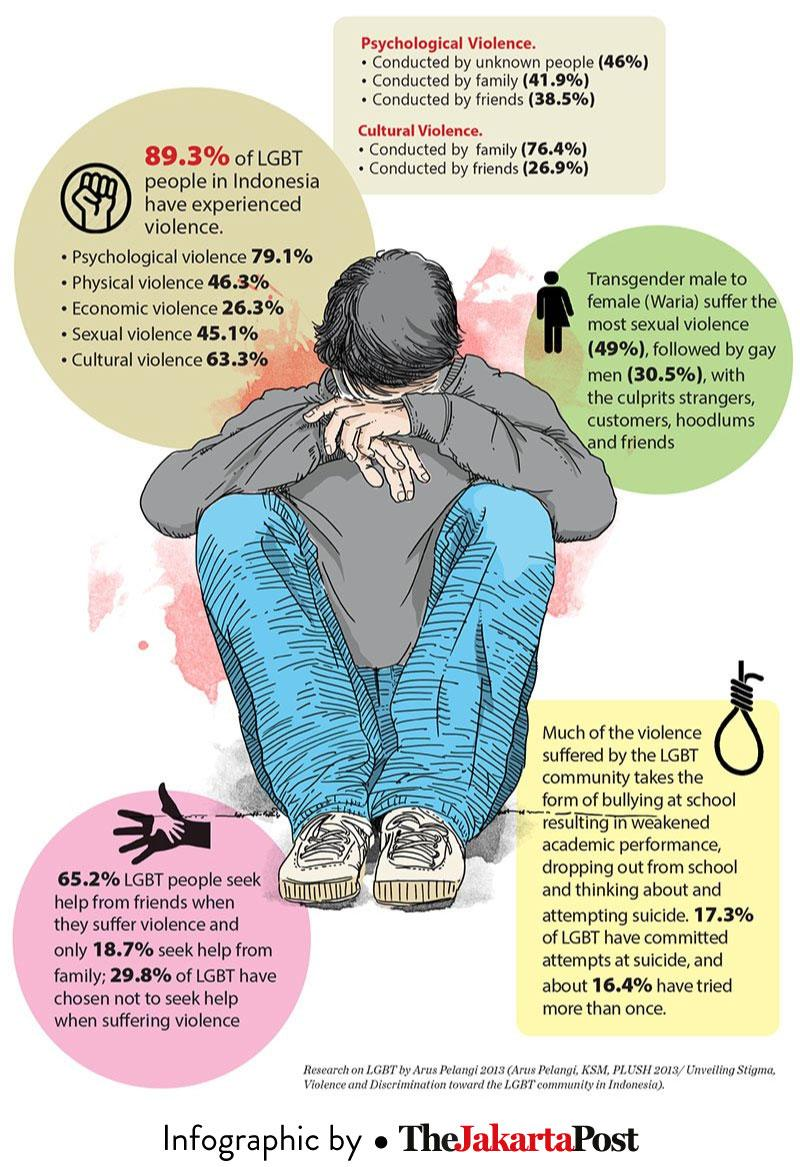Specify some key components in this picture. A recent study found that 30.5% of gay men have experienced sexual violence at the hands of strangers. A recent study conducted in Indonesia has found that 63.3% of LGBT individuals have experienced cultural violence. LGBT individuals are often more vulnerable to psychological violence, as opposed to physical violence, due to the societal stigma and discrimination they face. According to a study, 16.4% of LGBT individuals have attempted suicide more than once. According to a recent study, 18.7% of LGBT individuals seek help from their families when experiencing violence. 